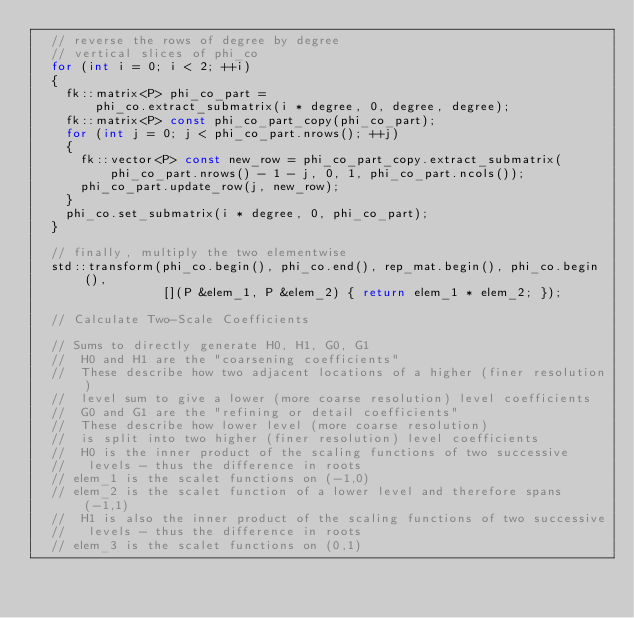<code> <loc_0><loc_0><loc_500><loc_500><_C++_>  // reverse the rows of degree by degree
  // vertical slices of phi_co
  for (int i = 0; i < 2; ++i)
  {
    fk::matrix<P> phi_co_part =
        phi_co.extract_submatrix(i * degree, 0, degree, degree);
    fk::matrix<P> const phi_co_part_copy(phi_co_part);
    for (int j = 0; j < phi_co_part.nrows(); ++j)
    {
      fk::vector<P> const new_row = phi_co_part_copy.extract_submatrix(
          phi_co_part.nrows() - 1 - j, 0, 1, phi_co_part.ncols());
      phi_co_part.update_row(j, new_row);
    }
    phi_co.set_submatrix(i * degree, 0, phi_co_part);
  }

  // finally, multiply the two elementwise
  std::transform(phi_co.begin(), phi_co.end(), rep_mat.begin(), phi_co.begin(),
                 [](P &elem_1, P &elem_2) { return elem_1 * elem_2; });

  // Calculate Two-Scale Coefficients

  // Sums to directly generate H0, H1, G0, G1
  //  H0 and H1 are the "coarsening coefficients"
  //  These describe how two adjacent locations of a higher (finer resolution)
  //  level sum to give a lower (more coarse resolution) level coefficients
  //  G0 and G1 are the "refining or detail coefficients"
  //  These describe how lower level (more coarse resolution)
  //  is split into two higher (finer resolution) level coefficients
  //  H0 is the inner product of the scaling functions of two successive
  //   levels - thus the difference in roots
  // elem_1 is the scalet functions on (-1,0)
  // elem_2 is the scalet function of a lower level and therefore spans (-1,1)
  //  H1 is also the inner product of the scaling functions of two successive
  //   levels - thus the difference in roots
  // elem_3 is the scalet functions on (0,1)</code> 